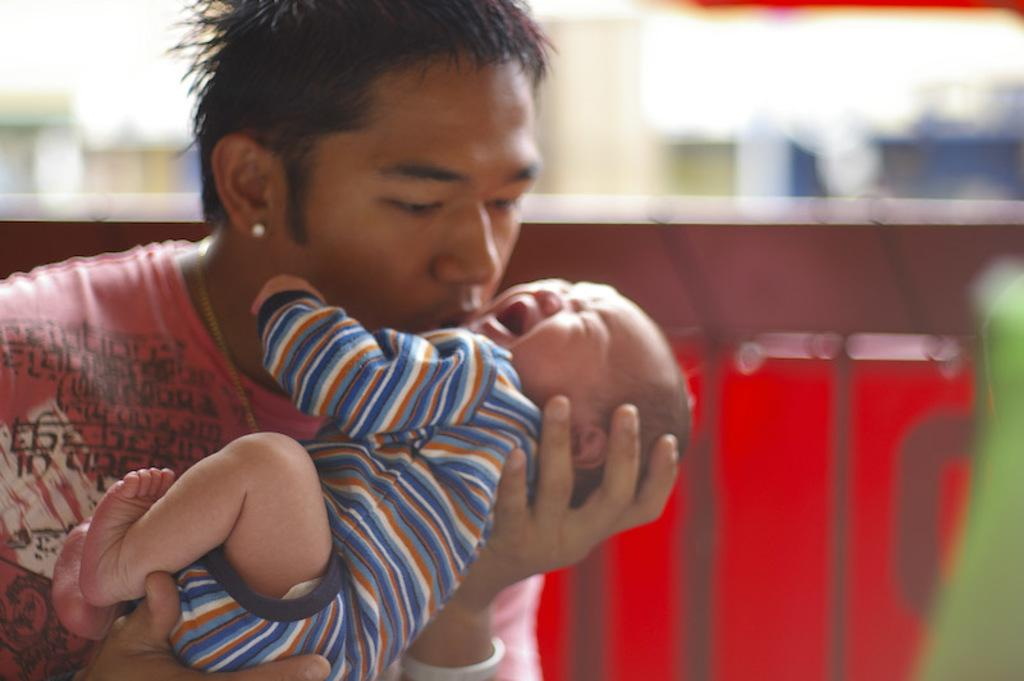What is the person in the image doing? The person is holding a baby in the image. What can be seen in the background of the image? There is a wall in the background of the image. What decision did the baby make in the image? The baby is not capable of making decisions in the image, as they are a baby. 